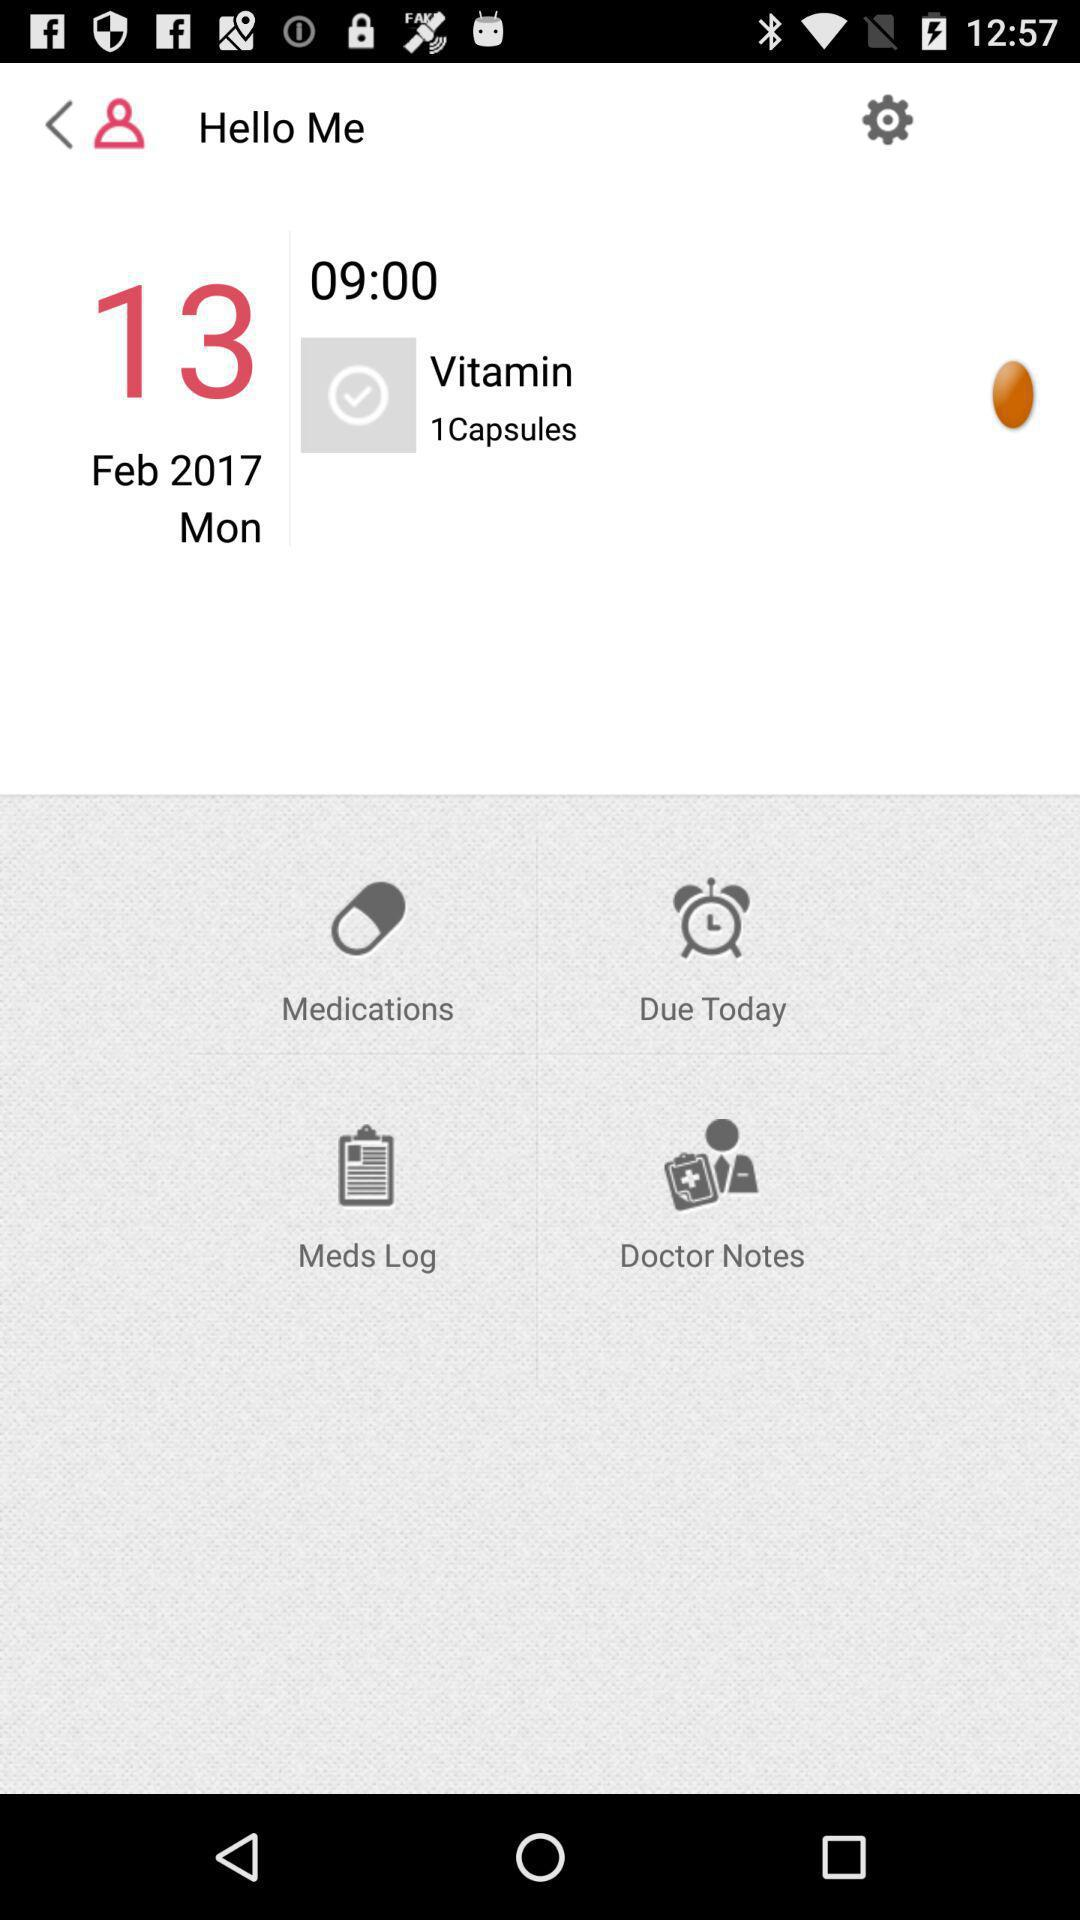At what time are the vitamin capsules to be taken? You have to take vitamin capsules at 09:00. 